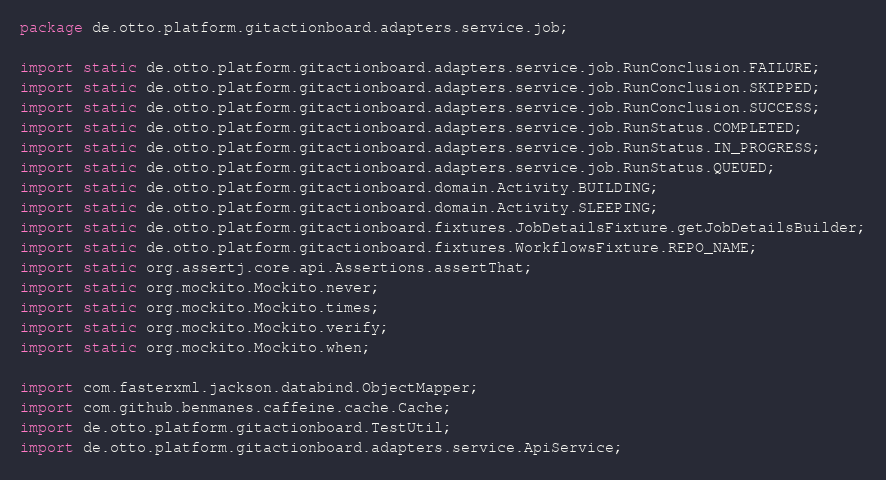<code> <loc_0><loc_0><loc_500><loc_500><_Java_>package de.otto.platform.gitactionboard.adapters.service.job;

import static de.otto.platform.gitactionboard.adapters.service.job.RunConclusion.FAILURE;
import static de.otto.platform.gitactionboard.adapters.service.job.RunConclusion.SKIPPED;
import static de.otto.platform.gitactionboard.adapters.service.job.RunConclusion.SUCCESS;
import static de.otto.platform.gitactionboard.adapters.service.job.RunStatus.COMPLETED;
import static de.otto.platform.gitactionboard.adapters.service.job.RunStatus.IN_PROGRESS;
import static de.otto.platform.gitactionboard.adapters.service.job.RunStatus.QUEUED;
import static de.otto.platform.gitactionboard.domain.Activity.BUILDING;
import static de.otto.platform.gitactionboard.domain.Activity.SLEEPING;
import static de.otto.platform.gitactionboard.fixtures.JobDetailsFixture.getJobDetailsBuilder;
import static de.otto.platform.gitactionboard.fixtures.WorkflowsFixture.REPO_NAME;
import static org.assertj.core.api.Assertions.assertThat;
import static org.mockito.Mockito.never;
import static org.mockito.Mockito.times;
import static org.mockito.Mockito.verify;
import static org.mockito.Mockito.when;

import com.fasterxml.jackson.databind.ObjectMapper;
import com.github.benmanes.caffeine.cache.Cache;
import de.otto.platform.gitactionboard.TestUtil;
import de.otto.platform.gitactionboard.adapters.service.ApiService;</code> 